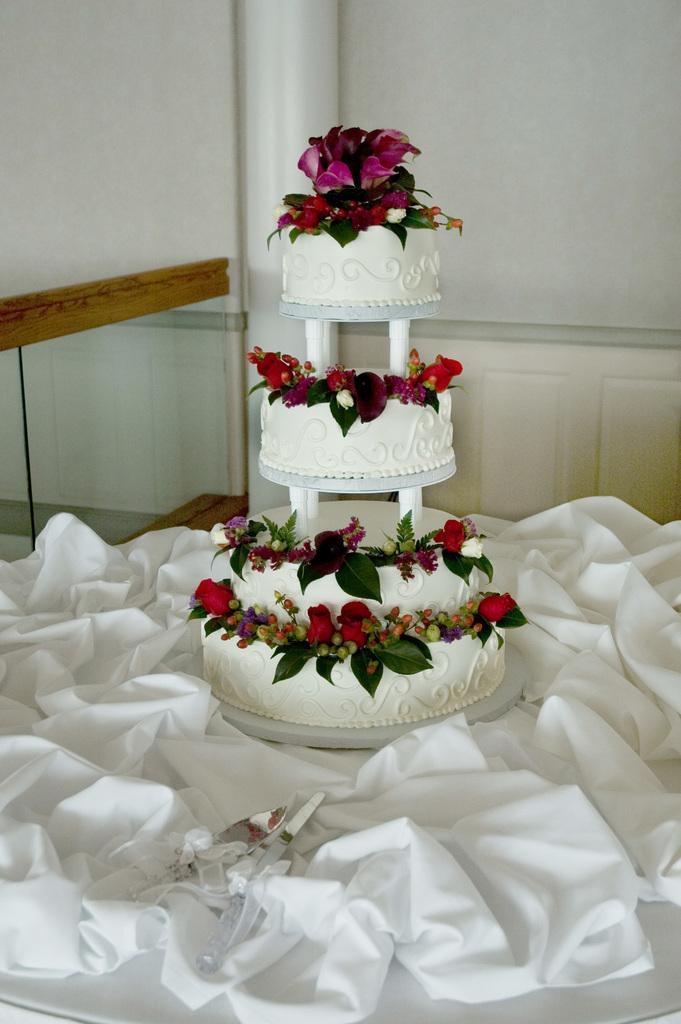What is on the table in the image? There is a cake on the table. What else is on the table besides the cake? There is a cloth and a knife on the table. What can be seen in the background of the image? There is a wall visible in the background. How many girls are present in the image? There is no mention of girls in the image, so it is not possible to determine their presence or number. 